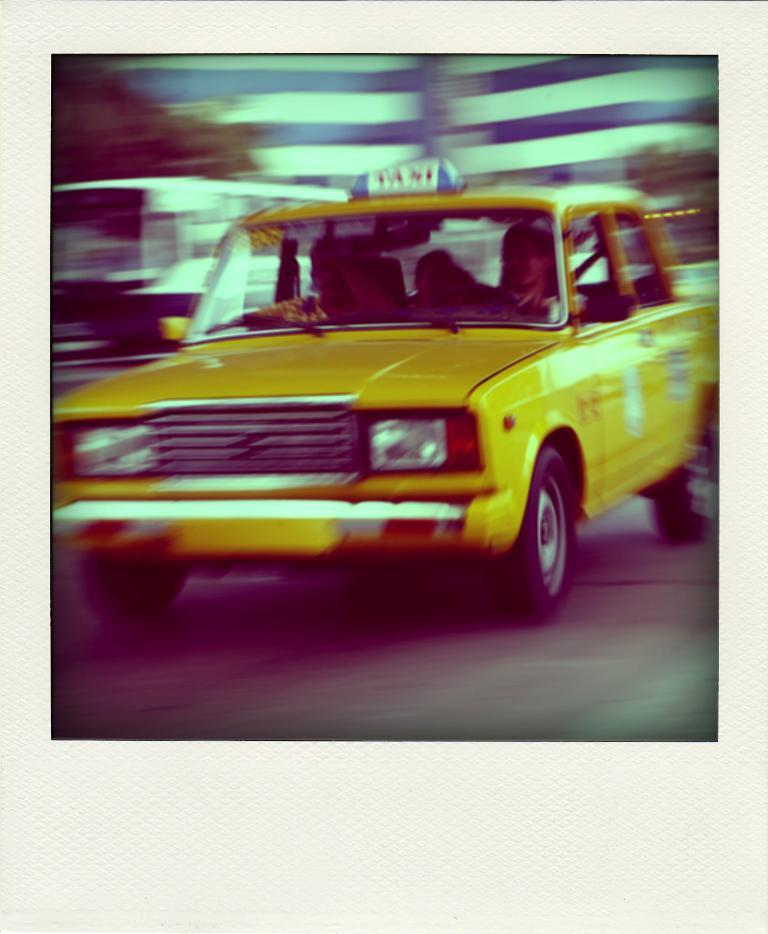<image>
Render a clear and concise summary of the photo. A yellow vehicle with the word Taxi on the top. 